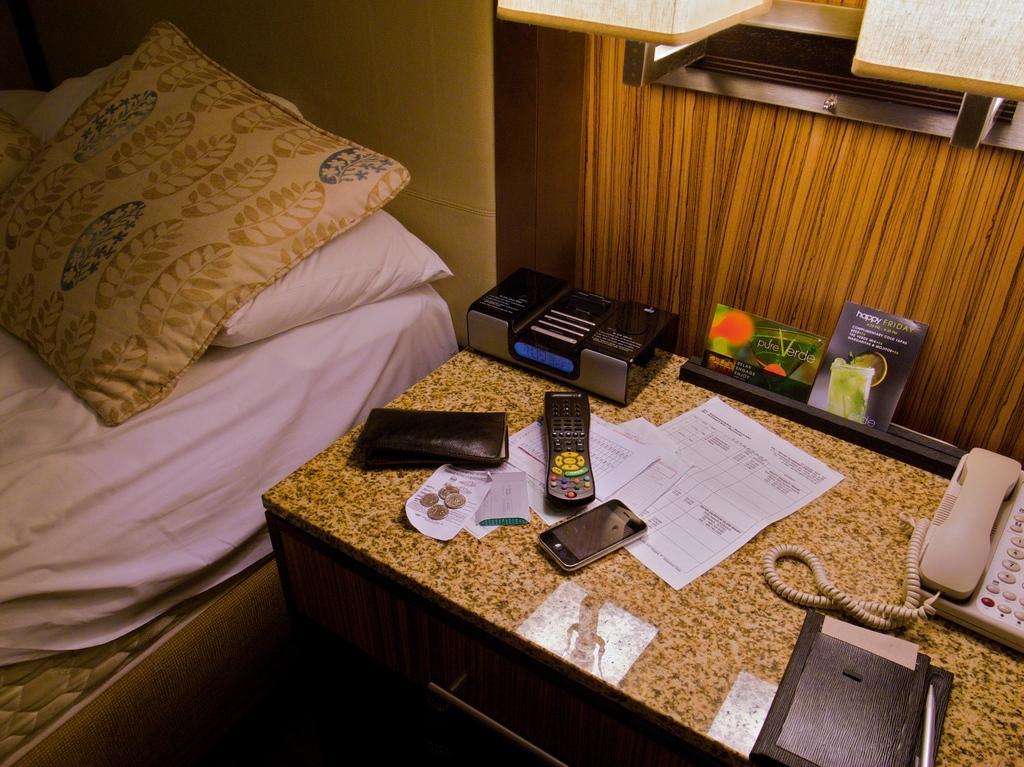Could you give a brief overview of what you see in this image? In the image we can see the bed and there are pillows on the bed. This is a mobile phone, remote, coins, paper, telephone, cable wire, book, pen and other objects. 